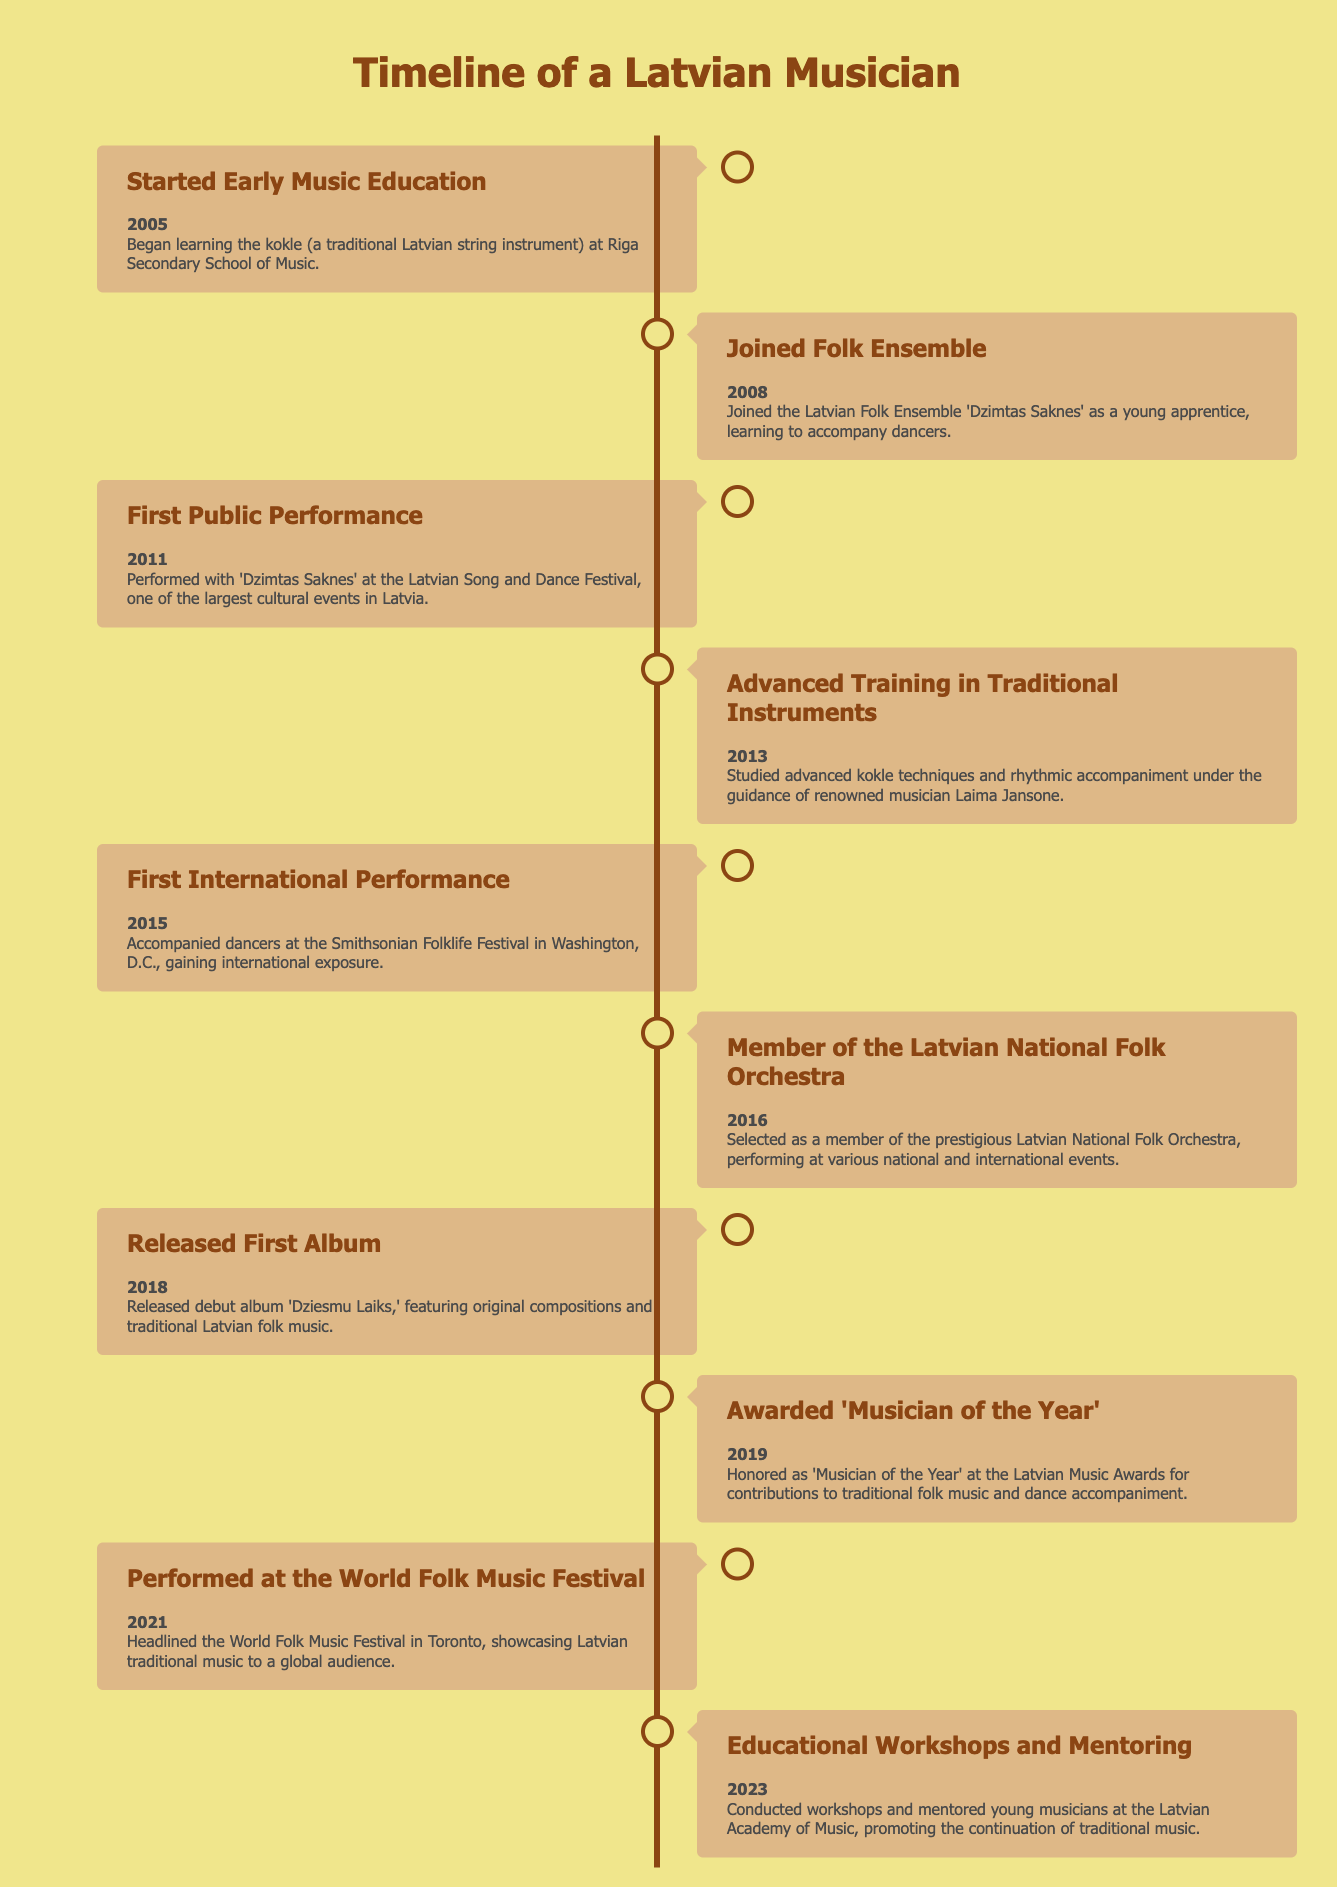What year did the musician start early music education? The timeline indicates that early music education began in 2005.
Answer: 2005 Which folk ensemble did the musician join in 2008? The musician joined the Latvian Folk Ensemble 'Dzimtas Saknes' in 2008.
Answer: 'Dzimtas Saknes' What significant event occurred in 2011 for the musician? In 2011, the musician performed at the Latvian Song and Dance Festival for the first time.
Answer: First Public Performance Who was the renowned musician that guided the artist's advanced training in 2013? The musician studied under Laima Jansone in 2013.
Answer: Laima Jansone What was the name of the musician's debut album released in 2018? The debut album released in 2018 was titled 'Dziesmu Laiks.'
Answer: 'Dziesmu Laiks' In what year was the musician awarded 'Musician of the Year'? The award was given in 2019.
Answer: 2019 How many years passed between the first public performance and the first international performance? The first public performance was in 2011, and the first international performance occurred in 2015, which is a four-year gap.
Answer: 4 years What type of activities did the musician engage in during 2023? The timeline indicates the musician conducted workshops and mentored young musicians in 2023.
Answer: Workshops and Mentoring What major festival did the musician headline in 2021? The musician headlined the World Folk Music Festival in 2021.
Answer: World Folk Music Festival 